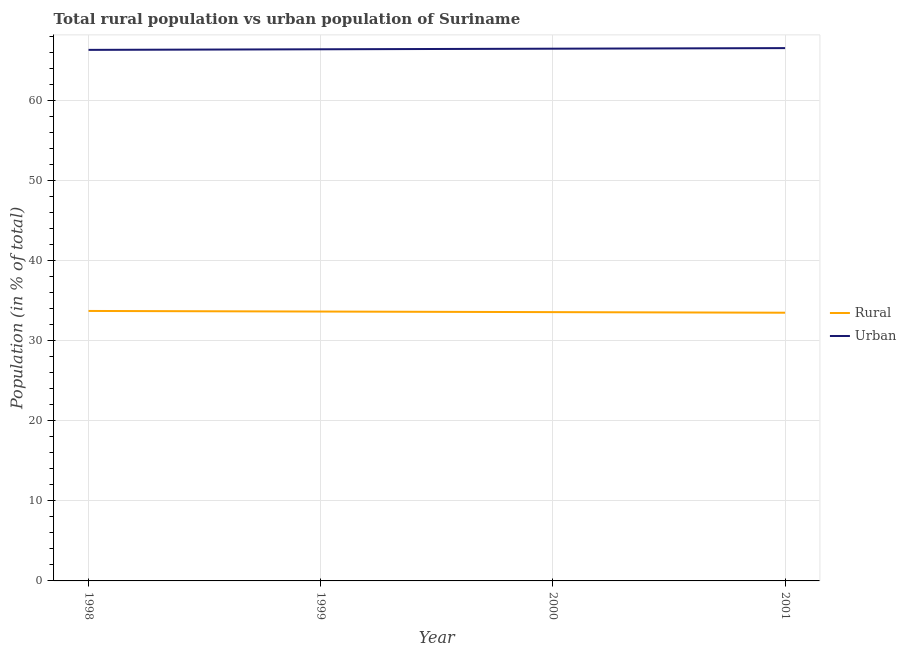How many different coloured lines are there?
Provide a succinct answer. 2. What is the urban population in 1998?
Make the answer very short. 66.3. Across all years, what is the maximum urban population?
Make the answer very short. 66.52. Across all years, what is the minimum urban population?
Provide a succinct answer. 66.3. In which year was the urban population maximum?
Keep it short and to the point. 2001. What is the total rural population in the graph?
Your response must be concise. 134.37. What is the difference between the urban population in 1998 and that in 1999?
Provide a succinct answer. -0.07. What is the difference between the rural population in 1999 and the urban population in 1998?
Keep it short and to the point. -32.67. What is the average rural population per year?
Provide a succinct answer. 33.59. In the year 1999, what is the difference between the urban population and rural population?
Offer a terse response. 32.74. What is the ratio of the urban population in 1998 to that in 2001?
Ensure brevity in your answer.  1. Is the urban population in 1999 less than that in 2000?
Provide a succinct answer. Yes. Is the difference between the rural population in 1999 and 2001 greater than the difference between the urban population in 1999 and 2001?
Provide a succinct answer. Yes. What is the difference between the highest and the second highest rural population?
Your answer should be compact. 0.07. What is the difference between the highest and the lowest rural population?
Keep it short and to the point. 0.22. In how many years, is the urban population greater than the average urban population taken over all years?
Your answer should be compact. 2. Is the rural population strictly greater than the urban population over the years?
Your answer should be compact. No. Is the rural population strictly less than the urban population over the years?
Your answer should be very brief. Yes. How many lines are there?
Keep it short and to the point. 2. Does the graph contain any zero values?
Make the answer very short. No. How are the legend labels stacked?
Your answer should be compact. Vertical. What is the title of the graph?
Make the answer very short. Total rural population vs urban population of Suriname. What is the label or title of the Y-axis?
Your answer should be compact. Population (in % of total). What is the Population (in % of total) of Rural in 1998?
Offer a terse response. 33.7. What is the Population (in % of total) of Urban in 1998?
Offer a terse response. 66.3. What is the Population (in % of total) in Rural in 1999?
Your answer should be very brief. 33.63. What is the Population (in % of total) of Urban in 1999?
Ensure brevity in your answer.  66.37. What is the Population (in % of total) in Rural in 2000?
Your answer should be very brief. 33.56. What is the Population (in % of total) in Urban in 2000?
Give a very brief answer. 66.44. What is the Population (in % of total) in Rural in 2001?
Give a very brief answer. 33.48. What is the Population (in % of total) of Urban in 2001?
Provide a succinct answer. 66.52. Across all years, what is the maximum Population (in % of total) of Rural?
Ensure brevity in your answer.  33.7. Across all years, what is the maximum Population (in % of total) of Urban?
Make the answer very short. 66.52. Across all years, what is the minimum Population (in % of total) of Rural?
Provide a short and direct response. 33.48. Across all years, what is the minimum Population (in % of total) in Urban?
Provide a short and direct response. 66.3. What is the total Population (in % of total) in Rural in the graph?
Your answer should be compact. 134.37. What is the total Population (in % of total) of Urban in the graph?
Keep it short and to the point. 265.63. What is the difference between the Population (in % of total) of Rural in 1998 and that in 1999?
Give a very brief answer. 0.07. What is the difference between the Population (in % of total) in Urban in 1998 and that in 1999?
Give a very brief answer. -0.07. What is the difference between the Population (in % of total) in Rural in 1998 and that in 2000?
Offer a very short reply. 0.15. What is the difference between the Population (in % of total) in Urban in 1998 and that in 2000?
Your response must be concise. -0.15. What is the difference between the Population (in % of total) in Rural in 1998 and that in 2001?
Provide a succinct answer. 0.22. What is the difference between the Population (in % of total) in Urban in 1998 and that in 2001?
Offer a terse response. -0.22. What is the difference between the Population (in % of total) in Rural in 1999 and that in 2000?
Provide a short and direct response. 0.07. What is the difference between the Population (in % of total) of Urban in 1999 and that in 2000?
Give a very brief answer. -0.07. What is the difference between the Population (in % of total) in Rural in 1999 and that in 2001?
Provide a succinct answer. 0.15. What is the difference between the Population (in % of total) in Urban in 1999 and that in 2001?
Offer a terse response. -0.15. What is the difference between the Population (in % of total) of Rural in 2000 and that in 2001?
Ensure brevity in your answer.  0.07. What is the difference between the Population (in % of total) in Urban in 2000 and that in 2001?
Your response must be concise. -0.07. What is the difference between the Population (in % of total) of Rural in 1998 and the Population (in % of total) of Urban in 1999?
Keep it short and to the point. -32.67. What is the difference between the Population (in % of total) in Rural in 1998 and the Population (in % of total) in Urban in 2000?
Your response must be concise. -32.74. What is the difference between the Population (in % of total) of Rural in 1998 and the Population (in % of total) of Urban in 2001?
Your answer should be very brief. -32.81. What is the difference between the Population (in % of total) of Rural in 1999 and the Population (in % of total) of Urban in 2000?
Your answer should be very brief. -32.81. What is the difference between the Population (in % of total) in Rural in 1999 and the Population (in % of total) in Urban in 2001?
Your answer should be compact. -32.89. What is the difference between the Population (in % of total) in Rural in 2000 and the Population (in % of total) in Urban in 2001?
Provide a short and direct response. -32.96. What is the average Population (in % of total) in Rural per year?
Keep it short and to the point. 33.59. What is the average Population (in % of total) of Urban per year?
Your response must be concise. 66.41. In the year 1998, what is the difference between the Population (in % of total) in Rural and Population (in % of total) in Urban?
Your answer should be very brief. -32.59. In the year 1999, what is the difference between the Population (in % of total) in Rural and Population (in % of total) in Urban?
Your answer should be very brief. -32.74. In the year 2000, what is the difference between the Population (in % of total) in Rural and Population (in % of total) in Urban?
Offer a terse response. -32.89. In the year 2001, what is the difference between the Population (in % of total) in Rural and Population (in % of total) in Urban?
Your answer should be compact. -33.03. What is the ratio of the Population (in % of total) in Urban in 1998 to that in 1999?
Provide a short and direct response. 1. What is the ratio of the Population (in % of total) in Rural in 1998 to that in 2000?
Offer a very short reply. 1. What is the ratio of the Population (in % of total) of Urban in 1998 to that in 2000?
Offer a terse response. 1. What is the ratio of the Population (in % of total) of Rural in 1998 to that in 2001?
Keep it short and to the point. 1.01. What is the ratio of the Population (in % of total) in Urban in 1998 to that in 2001?
Your answer should be compact. 1. What is the ratio of the Population (in % of total) in Rural in 1999 to that in 2000?
Your answer should be compact. 1. What is the ratio of the Population (in % of total) of Urban in 1999 to that in 2000?
Offer a very short reply. 1. What is the ratio of the Population (in % of total) in Rural in 1999 to that in 2001?
Your answer should be very brief. 1. What is the ratio of the Population (in % of total) in Rural in 2000 to that in 2001?
Make the answer very short. 1. What is the ratio of the Population (in % of total) in Urban in 2000 to that in 2001?
Ensure brevity in your answer.  1. What is the difference between the highest and the second highest Population (in % of total) in Rural?
Your answer should be compact. 0.07. What is the difference between the highest and the second highest Population (in % of total) of Urban?
Provide a short and direct response. 0.07. What is the difference between the highest and the lowest Population (in % of total) in Rural?
Offer a very short reply. 0.22. What is the difference between the highest and the lowest Population (in % of total) of Urban?
Your answer should be very brief. 0.22. 